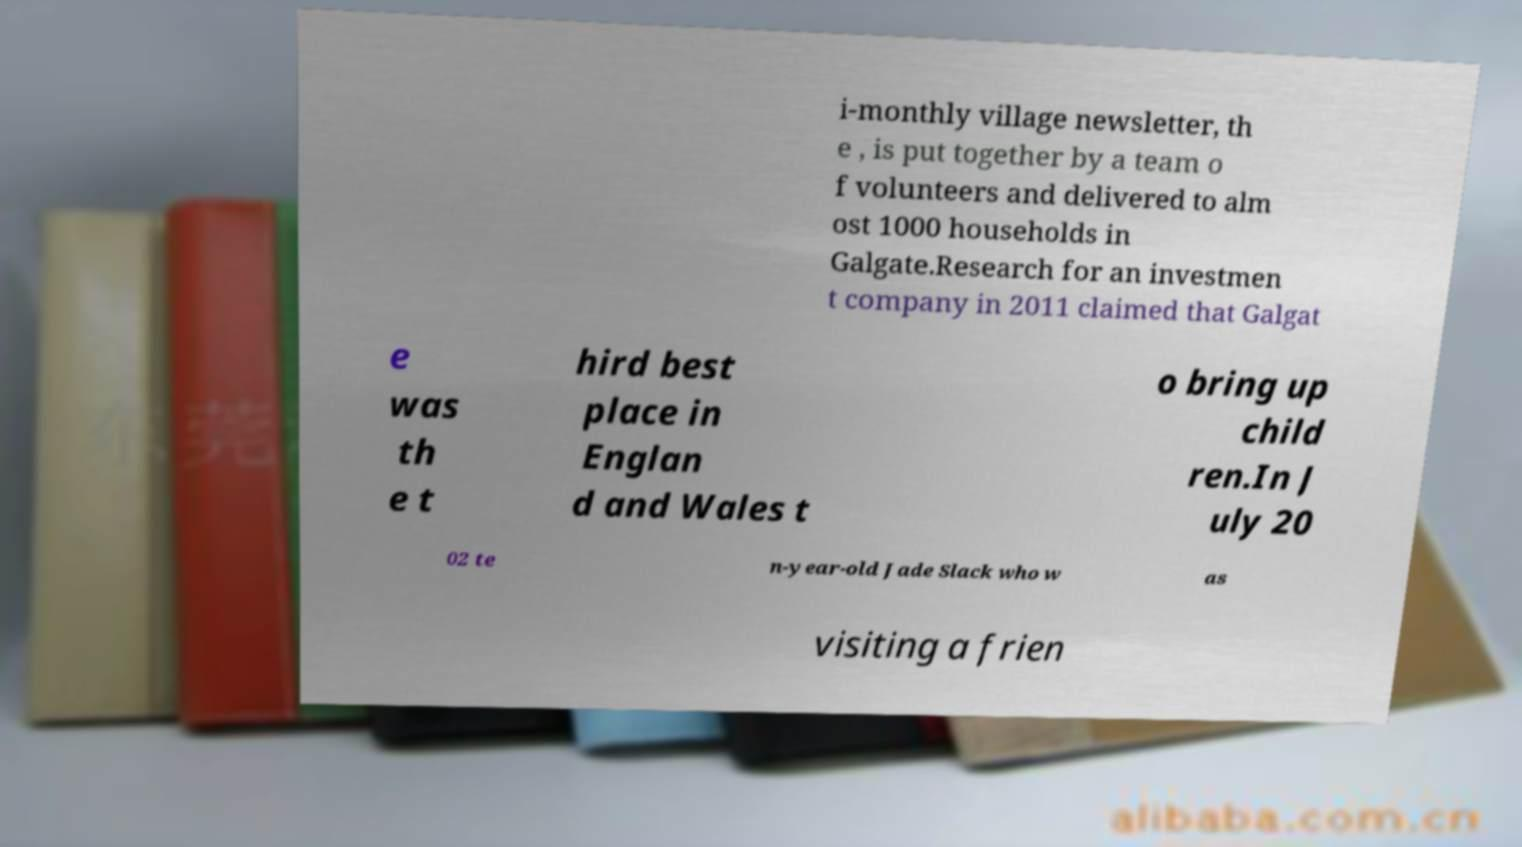Could you extract and type out the text from this image? i-monthly village newsletter, th e , is put together by a team o f volunteers and delivered to alm ost 1000 households in Galgate.Research for an investmen t company in 2011 claimed that Galgat e was th e t hird best place in Englan d and Wales t o bring up child ren.In J uly 20 02 te n-year-old Jade Slack who w as visiting a frien 